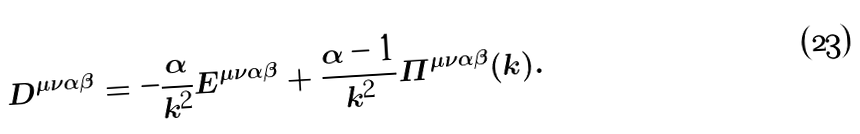<formula> <loc_0><loc_0><loc_500><loc_500>D ^ { \mu \nu \alpha \beta } = - \frac { \alpha } { k ^ { 2 } } E ^ { \mu \nu \alpha \beta } + \frac { \alpha - 1 } { k ^ { 2 } } \Pi ^ { \mu \nu \alpha \beta } ( k ) .</formula> 